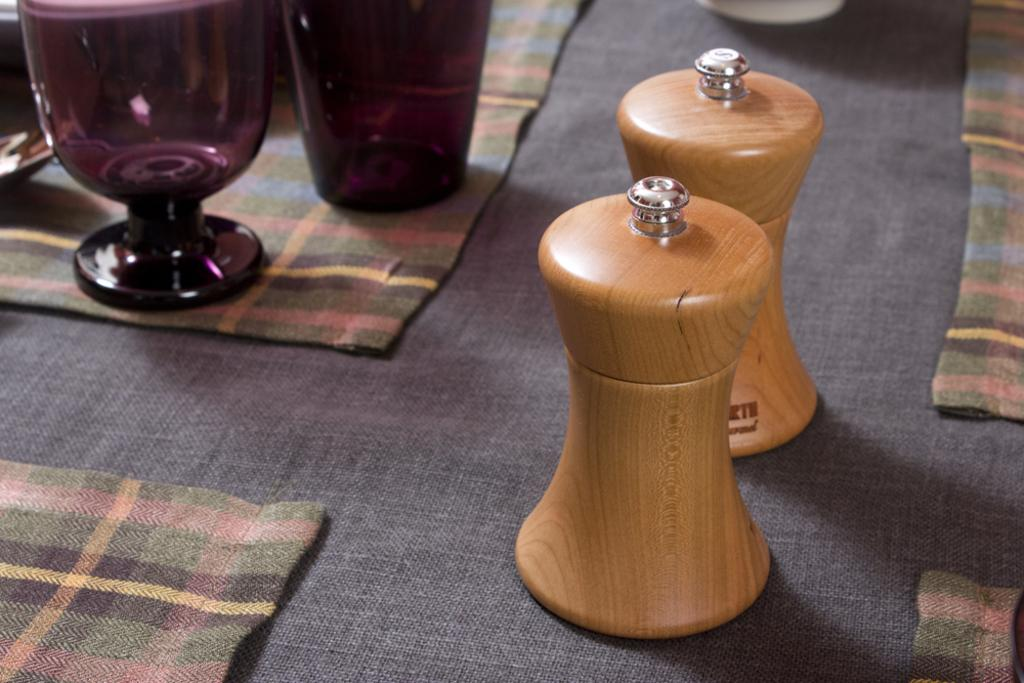What is the primary object made of glass in the image? There is a glass in the image. What type of material is used for the other objects in the image? There are wooden objects in the image. Can you describe the "other thing" on a cloth in the image? Unfortunately, the facts provided do not specify what the "other thing" is, only that it is on a cloth. How many eyes can be seen on the glass in the image? There are no eyes visible on the glass in the image, as it is an inanimate object. 